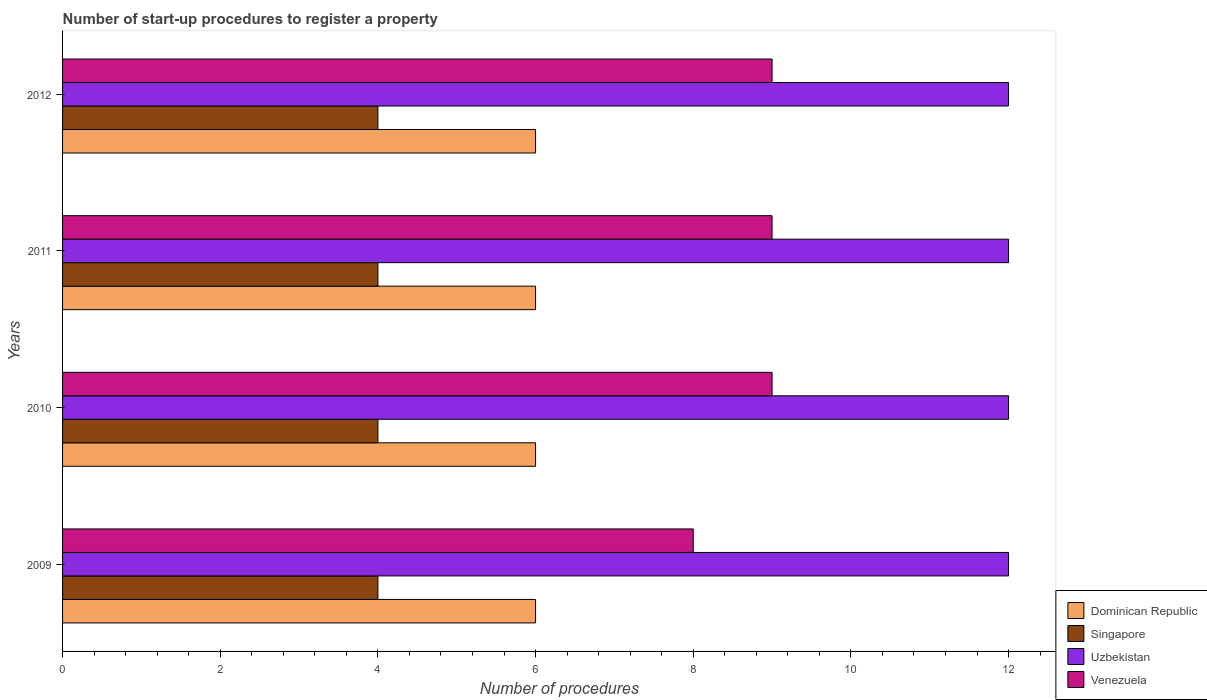How many different coloured bars are there?
Provide a short and direct response. 4. How many groups of bars are there?
Offer a very short reply. 4. Are the number of bars on each tick of the Y-axis equal?
Keep it short and to the point. Yes. How many bars are there on the 2nd tick from the top?
Provide a short and direct response. 4. How many bars are there on the 1st tick from the bottom?
Provide a short and direct response. 4. In how many cases, is the number of bars for a given year not equal to the number of legend labels?
Offer a very short reply. 0. What is the number of procedures required to register a property in Venezuela in 2012?
Offer a very short reply. 9. Across all years, what is the maximum number of procedures required to register a property in Uzbekistan?
Give a very brief answer. 12. Across all years, what is the minimum number of procedures required to register a property in Uzbekistan?
Provide a short and direct response. 12. In which year was the number of procedures required to register a property in Venezuela maximum?
Make the answer very short. 2010. What is the total number of procedures required to register a property in Uzbekistan in the graph?
Keep it short and to the point. 48. What is the difference between the number of procedures required to register a property in Singapore in 2010 and the number of procedures required to register a property in Dominican Republic in 2009?
Make the answer very short. -2. What is the average number of procedures required to register a property in Uzbekistan per year?
Offer a terse response. 12. In the year 2010, what is the difference between the number of procedures required to register a property in Singapore and number of procedures required to register a property in Uzbekistan?
Keep it short and to the point. -8. Is the number of procedures required to register a property in Uzbekistan in 2011 less than that in 2012?
Offer a terse response. No. What is the difference between the highest and the second highest number of procedures required to register a property in Singapore?
Keep it short and to the point. 0. In how many years, is the number of procedures required to register a property in Singapore greater than the average number of procedures required to register a property in Singapore taken over all years?
Your answer should be compact. 0. What does the 2nd bar from the top in 2009 represents?
Offer a very short reply. Uzbekistan. What does the 3rd bar from the bottom in 2009 represents?
Ensure brevity in your answer.  Uzbekistan. How many bars are there?
Make the answer very short. 16. Are all the bars in the graph horizontal?
Ensure brevity in your answer.  Yes. How many years are there in the graph?
Your answer should be very brief. 4. Does the graph contain grids?
Ensure brevity in your answer.  No. How many legend labels are there?
Offer a terse response. 4. What is the title of the graph?
Provide a short and direct response. Number of start-up procedures to register a property. Does "Trinidad and Tobago" appear as one of the legend labels in the graph?
Offer a very short reply. No. What is the label or title of the X-axis?
Keep it short and to the point. Number of procedures. What is the label or title of the Y-axis?
Provide a succinct answer. Years. What is the Number of procedures of Uzbekistan in 2009?
Ensure brevity in your answer.  12. What is the Number of procedures in Venezuela in 2009?
Offer a terse response. 8. What is the Number of procedures in Dominican Republic in 2010?
Provide a short and direct response. 6. What is the Number of procedures in Singapore in 2010?
Keep it short and to the point. 4. What is the Number of procedures in Uzbekistan in 2010?
Your response must be concise. 12. What is the Number of procedures of Venezuela in 2010?
Give a very brief answer. 9. What is the Number of procedures in Dominican Republic in 2011?
Give a very brief answer. 6. What is the Number of procedures of Venezuela in 2012?
Keep it short and to the point. 9. Across all years, what is the maximum Number of procedures of Uzbekistan?
Offer a terse response. 12. Across all years, what is the maximum Number of procedures in Venezuela?
Make the answer very short. 9. Across all years, what is the minimum Number of procedures of Singapore?
Your answer should be very brief. 4. What is the difference between the Number of procedures in Singapore in 2009 and that in 2010?
Offer a very short reply. 0. What is the difference between the Number of procedures of Uzbekistan in 2009 and that in 2010?
Make the answer very short. 0. What is the difference between the Number of procedures of Venezuela in 2009 and that in 2010?
Ensure brevity in your answer.  -1. What is the difference between the Number of procedures in Dominican Republic in 2009 and that in 2011?
Give a very brief answer. 0. What is the difference between the Number of procedures in Venezuela in 2009 and that in 2011?
Keep it short and to the point. -1. What is the difference between the Number of procedures in Dominican Republic in 2009 and that in 2012?
Ensure brevity in your answer.  0. What is the difference between the Number of procedures of Uzbekistan in 2009 and that in 2012?
Your answer should be very brief. 0. What is the difference between the Number of procedures in Singapore in 2010 and that in 2011?
Your answer should be compact. 0. What is the difference between the Number of procedures in Singapore in 2010 and that in 2012?
Make the answer very short. 0. What is the difference between the Number of procedures in Dominican Republic in 2011 and that in 2012?
Provide a succinct answer. 0. What is the difference between the Number of procedures of Uzbekistan in 2011 and that in 2012?
Your answer should be very brief. 0. What is the difference between the Number of procedures of Venezuela in 2011 and that in 2012?
Your answer should be compact. 0. What is the difference between the Number of procedures of Dominican Republic in 2009 and the Number of procedures of Venezuela in 2010?
Provide a short and direct response. -3. What is the difference between the Number of procedures in Singapore in 2009 and the Number of procedures in Venezuela in 2010?
Make the answer very short. -5. What is the difference between the Number of procedures of Uzbekistan in 2009 and the Number of procedures of Venezuela in 2010?
Your response must be concise. 3. What is the difference between the Number of procedures in Dominican Republic in 2009 and the Number of procedures in Uzbekistan in 2012?
Make the answer very short. -6. What is the difference between the Number of procedures of Dominican Republic in 2010 and the Number of procedures of Singapore in 2011?
Your response must be concise. 2. What is the difference between the Number of procedures in Dominican Republic in 2010 and the Number of procedures in Venezuela in 2011?
Ensure brevity in your answer.  -3. What is the difference between the Number of procedures in Singapore in 2010 and the Number of procedures in Uzbekistan in 2011?
Ensure brevity in your answer.  -8. What is the difference between the Number of procedures of Singapore in 2010 and the Number of procedures of Venezuela in 2011?
Your answer should be compact. -5. What is the difference between the Number of procedures of Dominican Republic in 2010 and the Number of procedures of Uzbekistan in 2012?
Keep it short and to the point. -6. What is the difference between the Number of procedures of Dominican Republic in 2010 and the Number of procedures of Venezuela in 2012?
Offer a very short reply. -3. What is the difference between the Number of procedures of Dominican Republic in 2011 and the Number of procedures of Singapore in 2012?
Provide a short and direct response. 2. What is the difference between the Number of procedures in Dominican Republic in 2011 and the Number of procedures in Uzbekistan in 2012?
Keep it short and to the point. -6. What is the difference between the Number of procedures of Singapore in 2011 and the Number of procedures of Uzbekistan in 2012?
Keep it short and to the point. -8. What is the difference between the Number of procedures in Singapore in 2011 and the Number of procedures in Venezuela in 2012?
Your answer should be very brief. -5. What is the difference between the Number of procedures in Uzbekistan in 2011 and the Number of procedures in Venezuela in 2012?
Provide a succinct answer. 3. What is the average Number of procedures in Dominican Republic per year?
Ensure brevity in your answer.  6. What is the average Number of procedures in Venezuela per year?
Offer a very short reply. 8.75. In the year 2009, what is the difference between the Number of procedures in Dominican Republic and Number of procedures in Singapore?
Ensure brevity in your answer.  2. In the year 2009, what is the difference between the Number of procedures of Dominican Republic and Number of procedures of Uzbekistan?
Your response must be concise. -6. In the year 2009, what is the difference between the Number of procedures of Dominican Republic and Number of procedures of Venezuela?
Keep it short and to the point. -2. In the year 2009, what is the difference between the Number of procedures in Uzbekistan and Number of procedures in Venezuela?
Offer a very short reply. 4. In the year 2010, what is the difference between the Number of procedures in Dominican Republic and Number of procedures in Singapore?
Your answer should be compact. 2. In the year 2010, what is the difference between the Number of procedures of Singapore and Number of procedures of Venezuela?
Offer a very short reply. -5. In the year 2011, what is the difference between the Number of procedures of Dominican Republic and Number of procedures of Uzbekistan?
Keep it short and to the point. -6. In the year 2011, what is the difference between the Number of procedures in Singapore and Number of procedures in Venezuela?
Offer a terse response. -5. In the year 2012, what is the difference between the Number of procedures of Dominican Republic and Number of procedures of Singapore?
Provide a succinct answer. 2. In the year 2012, what is the difference between the Number of procedures in Singapore and Number of procedures in Uzbekistan?
Ensure brevity in your answer.  -8. In the year 2012, what is the difference between the Number of procedures in Singapore and Number of procedures in Venezuela?
Offer a terse response. -5. What is the ratio of the Number of procedures in Dominican Republic in 2009 to that in 2010?
Your response must be concise. 1. What is the ratio of the Number of procedures of Uzbekistan in 2009 to that in 2012?
Offer a very short reply. 1. What is the ratio of the Number of procedures in Singapore in 2010 to that in 2011?
Provide a succinct answer. 1. What is the ratio of the Number of procedures in Uzbekistan in 2010 to that in 2011?
Your answer should be compact. 1. What is the ratio of the Number of procedures of Dominican Republic in 2010 to that in 2012?
Offer a terse response. 1. What is the ratio of the Number of procedures in Singapore in 2010 to that in 2012?
Make the answer very short. 1. What is the ratio of the Number of procedures of Uzbekistan in 2010 to that in 2012?
Your response must be concise. 1. What is the ratio of the Number of procedures of Venezuela in 2010 to that in 2012?
Your answer should be very brief. 1. What is the ratio of the Number of procedures in Dominican Republic in 2011 to that in 2012?
Your answer should be very brief. 1. What is the ratio of the Number of procedures of Singapore in 2011 to that in 2012?
Your answer should be very brief. 1. What is the difference between the highest and the second highest Number of procedures of Singapore?
Make the answer very short. 0. What is the difference between the highest and the second highest Number of procedures of Uzbekistan?
Your response must be concise. 0. What is the difference between the highest and the second highest Number of procedures in Venezuela?
Ensure brevity in your answer.  0. What is the difference between the highest and the lowest Number of procedures in Singapore?
Give a very brief answer. 0. What is the difference between the highest and the lowest Number of procedures in Uzbekistan?
Your answer should be very brief. 0. 